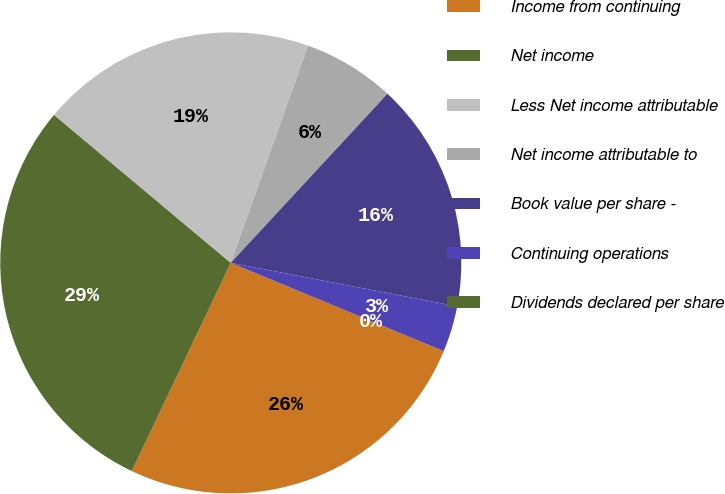Convert chart. <chart><loc_0><loc_0><loc_500><loc_500><pie_chart><fcel>Income from continuing<fcel>Net income<fcel>Less Net income attributable<fcel>Net income attributable to<fcel>Book value per share -<fcel>Continuing operations<fcel>Dividends declared per share<nl><fcel>25.81%<fcel>29.03%<fcel>19.35%<fcel>6.45%<fcel>16.13%<fcel>3.23%<fcel>0.0%<nl></chart> 